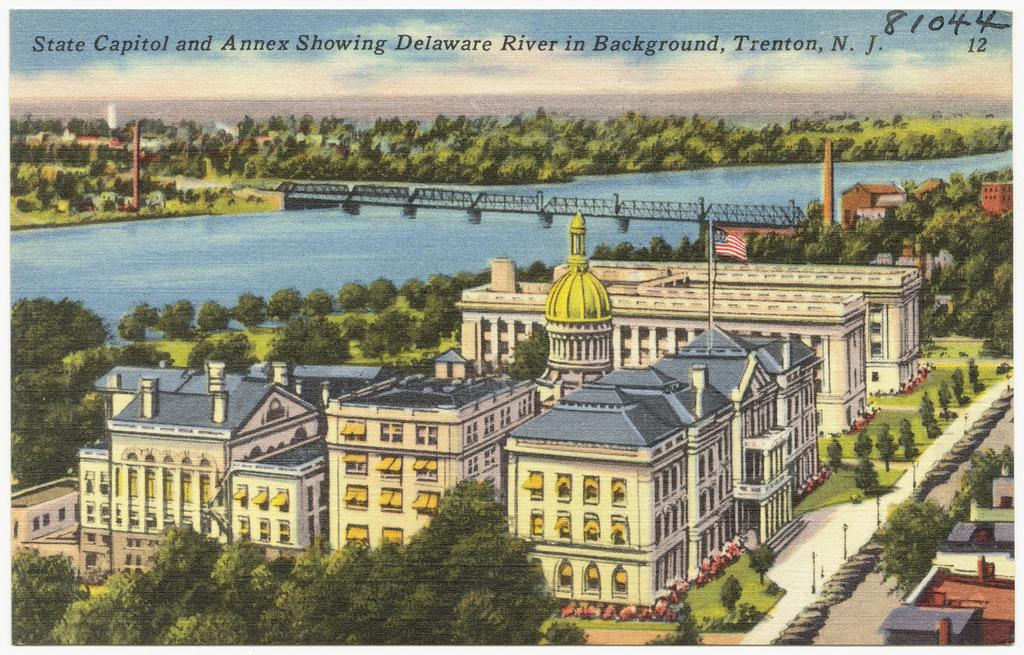Provide a one-sentence caption for the provided image. A postcard has the number 81044 written in the corner. 